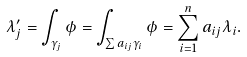<formula> <loc_0><loc_0><loc_500><loc_500>\lambda _ { j } ^ { \prime } = \int _ { \gamma _ { j } } \phi = \int _ { \sum a _ { i j } \gamma _ { i } } \phi = \sum _ { i = 1 } ^ { n } a _ { i j } \lambda _ { i } .</formula> 